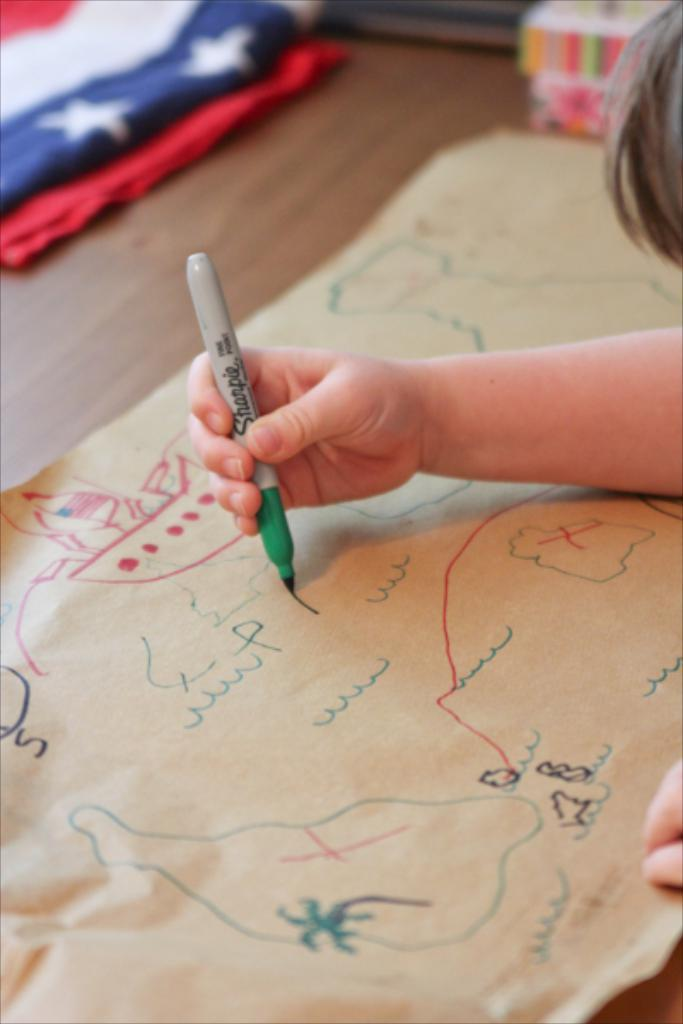What part of a person can be seen in the image? There is a person's hand in the image. What is the person doing with their hand? The person is drawing on a sheet. What tool is the person using to draw? The person is using a sketch. What else can be seen in the image besides the person's hand and the sheet? There is a cloth visible in the top left corner of the image. Can you see any streets in the image? There are no streets visible in the image. 